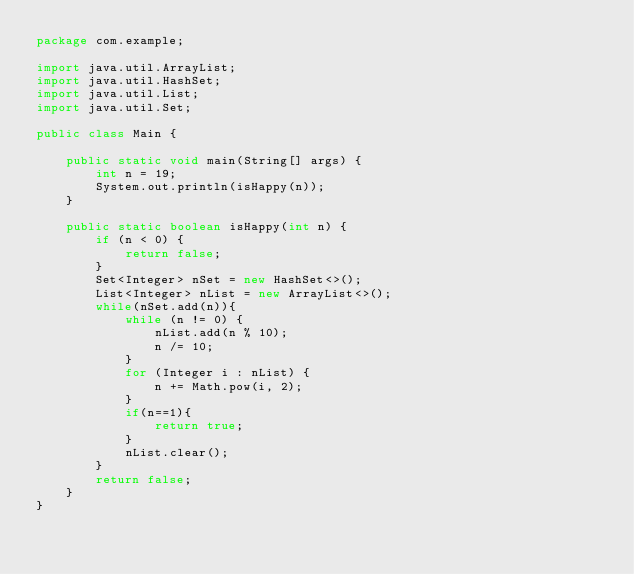<code> <loc_0><loc_0><loc_500><loc_500><_Java_>package com.example;

import java.util.ArrayList;
import java.util.HashSet;
import java.util.List;
import java.util.Set;

public class Main {

    public static void main(String[] args) {
        int n = 19;
        System.out.println(isHappy(n));
    }

    public static boolean isHappy(int n) {
        if (n < 0) {
            return false;
        }   
        Set<Integer> nSet = new HashSet<>();
        List<Integer> nList = new ArrayList<>();
        while(nSet.add(n)){
            while (n != 0) {
                nList.add(n % 10);
                n /= 10;
            }
            for (Integer i : nList) {
                n += Math.pow(i, 2);
            }
            if(n==1){
                return true;
            }
            nList.clear();
        }
        return false;
    }
}
</code> 